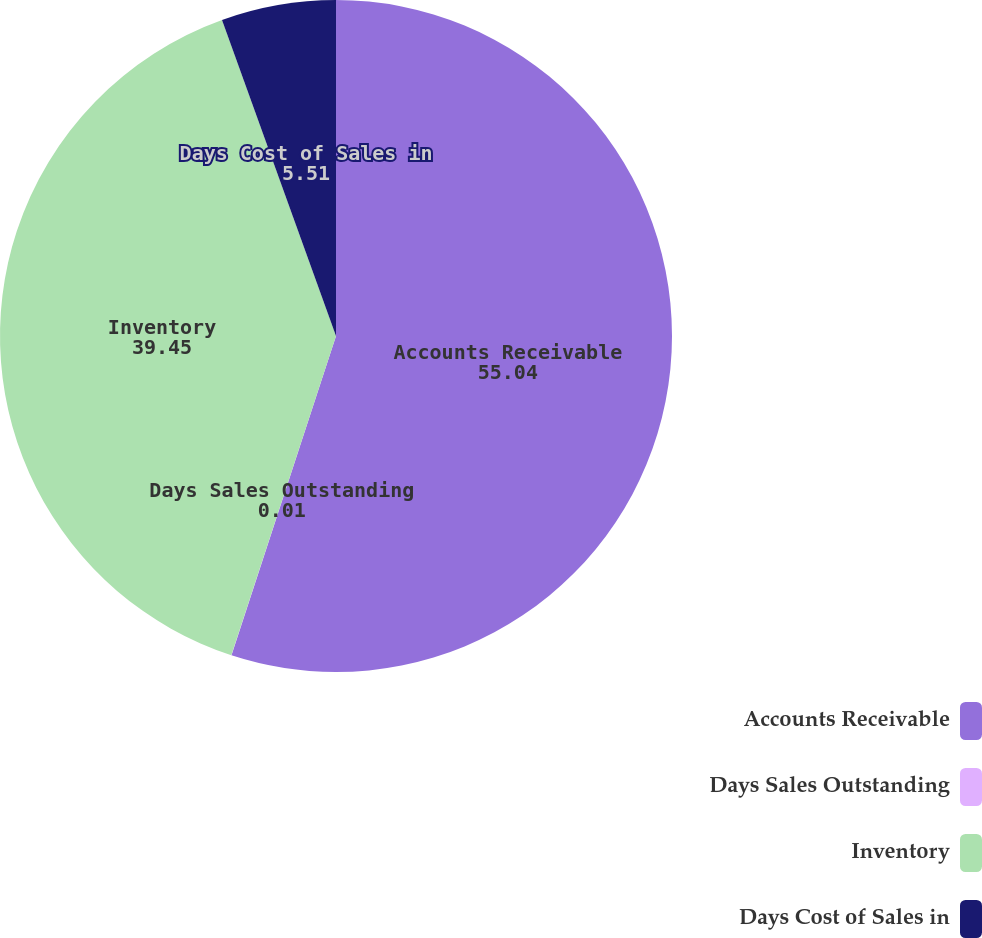Convert chart to OTSL. <chart><loc_0><loc_0><loc_500><loc_500><pie_chart><fcel>Accounts Receivable<fcel>Days Sales Outstanding<fcel>Inventory<fcel>Days Cost of Sales in<nl><fcel>55.04%<fcel>0.01%<fcel>39.45%<fcel>5.51%<nl></chart> 